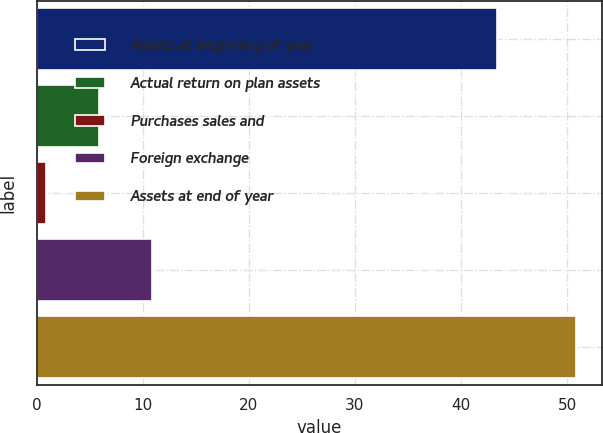<chart> <loc_0><loc_0><loc_500><loc_500><bar_chart><fcel>Assets at beginning of year<fcel>Actual return on plan assets<fcel>Purchases sales and<fcel>Foreign exchange<fcel>Assets at end of year<nl><fcel>43.4<fcel>5.89<fcel>0.9<fcel>10.88<fcel>50.8<nl></chart> 